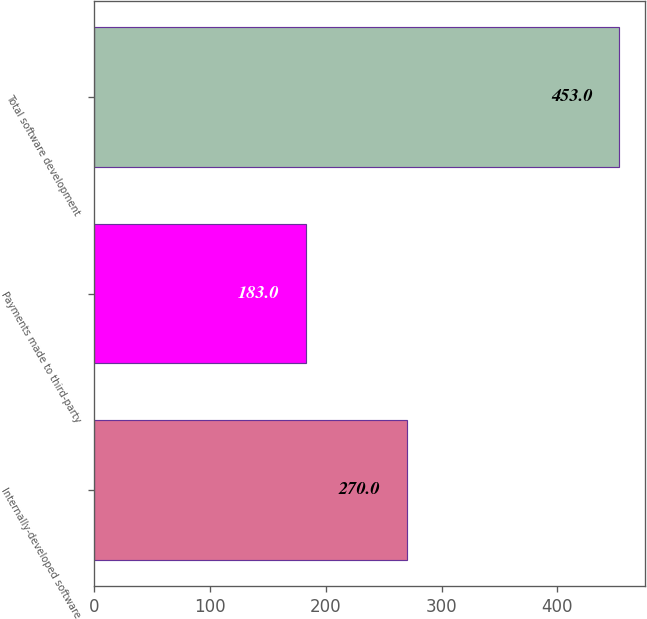<chart> <loc_0><loc_0><loc_500><loc_500><bar_chart><fcel>Internally-developed software<fcel>Payments made to third-party<fcel>Total software development<nl><fcel>270<fcel>183<fcel>453<nl></chart> 